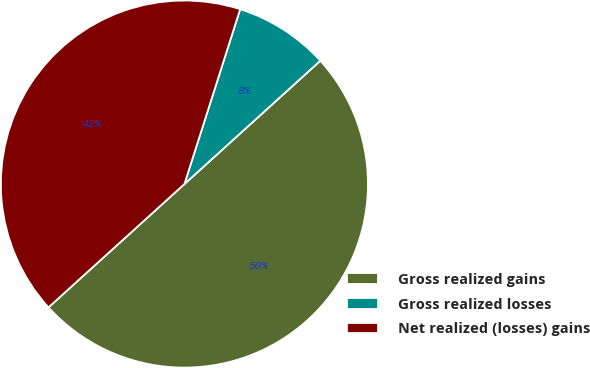Convert chart to OTSL. <chart><loc_0><loc_0><loc_500><loc_500><pie_chart><fcel>Gross realized gains<fcel>Gross realized losses<fcel>Net realized (losses) gains<nl><fcel>50.0%<fcel>8.36%<fcel>41.64%<nl></chart> 